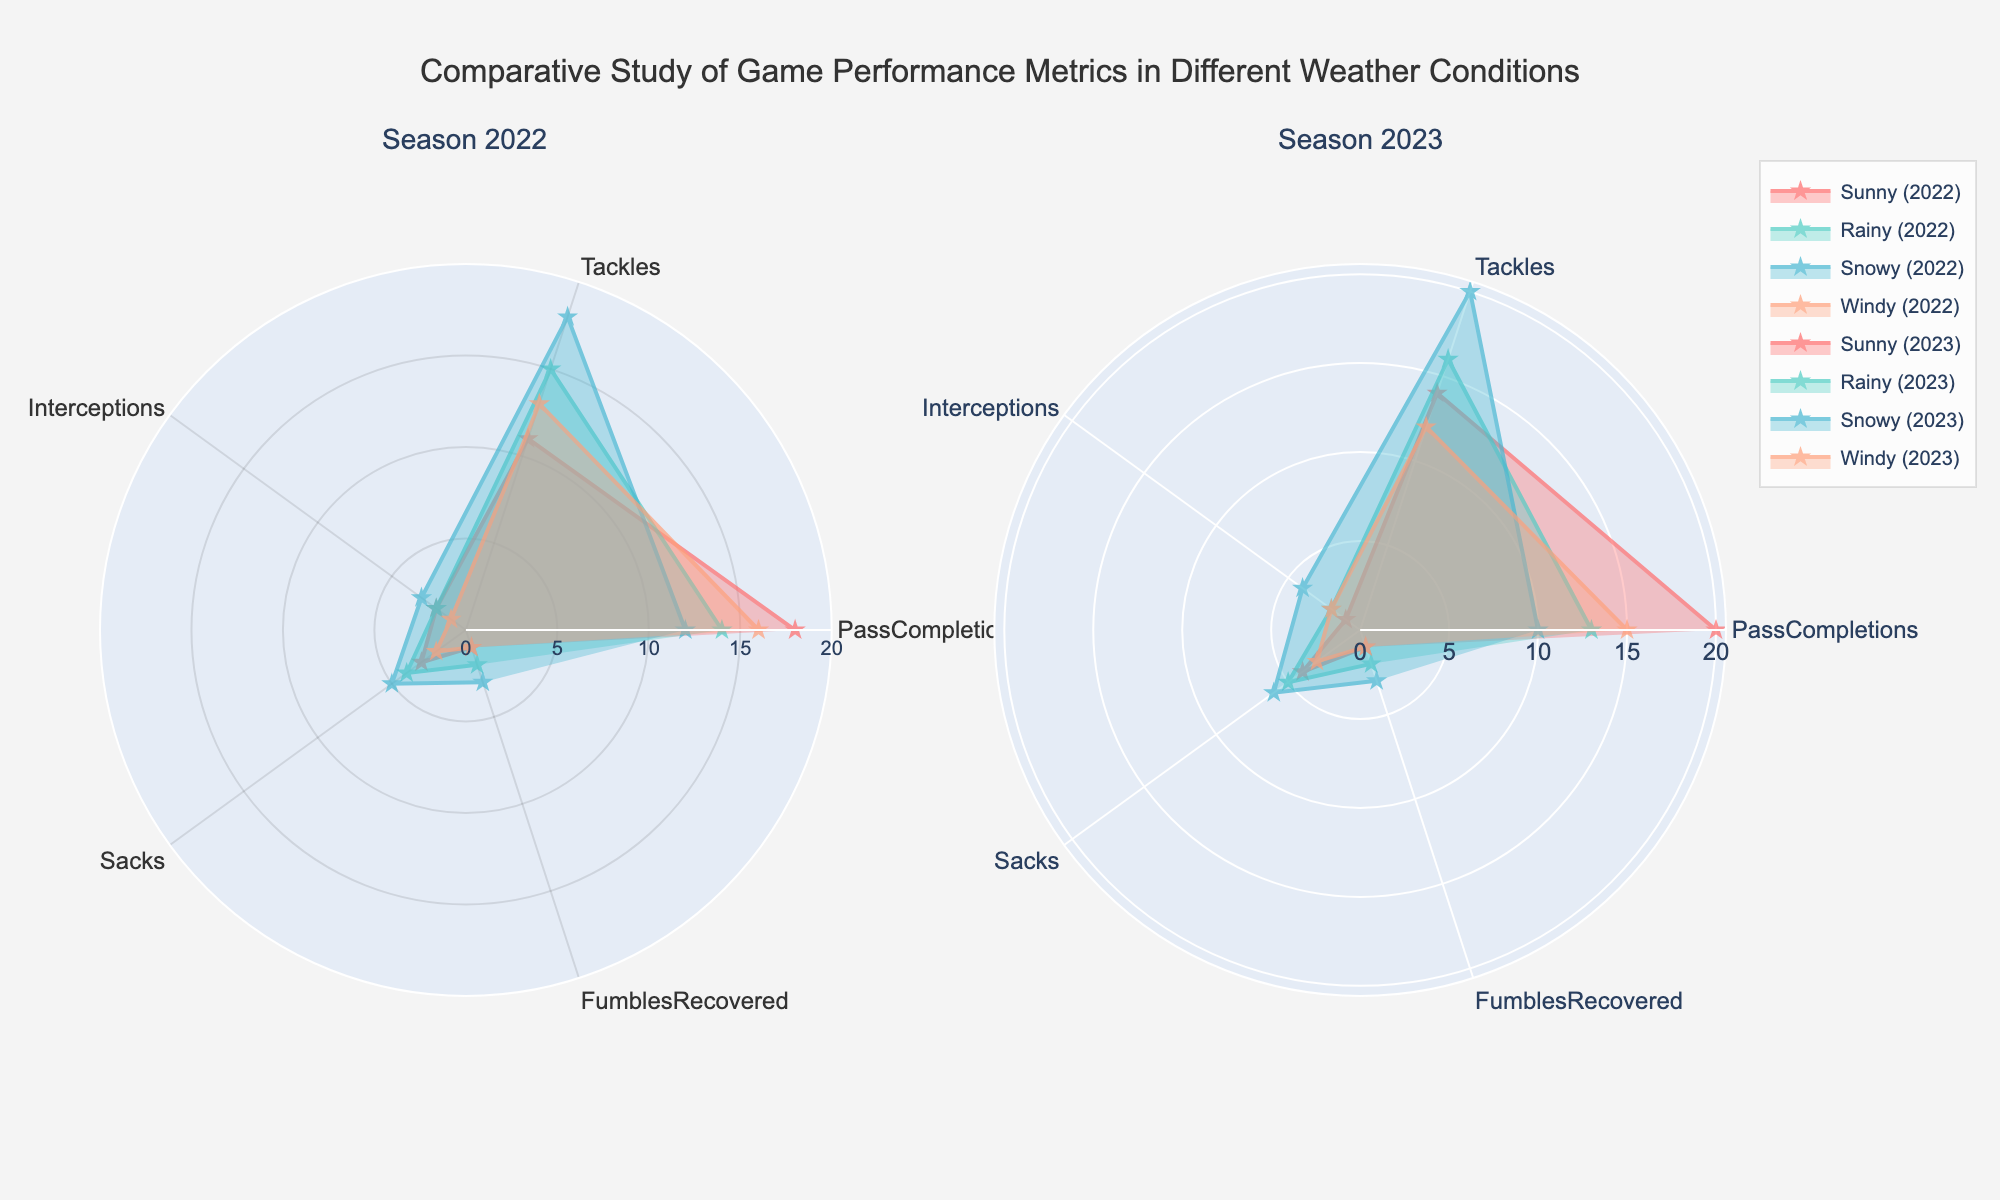What is the title of the figure? The title of the figure is usually found at the top and describes the main topic of the visual representation. In this case, it explains the comparative study of game performance metrics.
Answer: Comparative Study of Game Performance Metrics in Different Weather Conditions Which weather condition shows the highest number of sacks in the 2023 season? By looking at the plot for the 2023 season, we observe the radial distance in the plot representing 'Sacks'. The Snowy condition has the highest radial distance for sacks.
Answer: Snowy How do pass completions differ between Sunny and Snowy conditions in the 2022 season? To compare the pass completions, observe the value for the 'PassCompletions' metric for both Sunny and Snowy conditions in the 2022 subplot. Sunny has more pass completions than Snowy.
Answer: Sunny has more pass completions Are there more tackles made in Windy conditions in 2022 or 2023? Check the 'Tackles' metric for Windy conditions in both the 2022 and 2023 subplots. Compare the radial values to see which is higher. Windy conditions in 2022 have more tackles.
Answer: 2022 What's the average number of fumbles recovered across all weather conditions in the 2023 season? Add the number of fumbles recovered in each weather condition for the 2023 season and divide by the number of weather conditions: (1+2+3+1)/4.
Answer: 1.75 Which weather condition had the least interceptions in the 2022 season? Look at the radial distance for the 'Interceptions' metric under all weather conditions for the 2022 subplot. Windy conditions have the least number of interceptions.
Answer: Windy How do the number of tackles in Rainy conditions in the 2022 season compare to Sunny conditions in the 2023 season? Compare the 'Tackles' metric for Rainy conditions in 2022 with Sunny conditions in 2023 by checking the radial values. Rainy conditions in 2022 have more tackles than Sunny conditions in 2023.
Answer: Rainy conditions in 2022 have more tackles Which season showed better defensive performance in snowy conditions considering interceptions and sacks? Defensive performance can be considered based on higher interceptions and sacks. In Snowy conditions, the total number of interceptions and sacks should be compared between the two seasons: 2022 (3+5) vs. 2023 (4+6). The total for 2023 is higher.
Answer: 2023 What is the overall trend in tackles across different weather conditions in both seasons? Examine the radial values for 'Tackles' across all weather conditions in both seasons. In general, more tackles seem to be made under Snowy and Rainy conditions, while Sunny and Windy conditions tend to have fewer tackles.
Answer: Higher under Snowy and Rainy conditions 